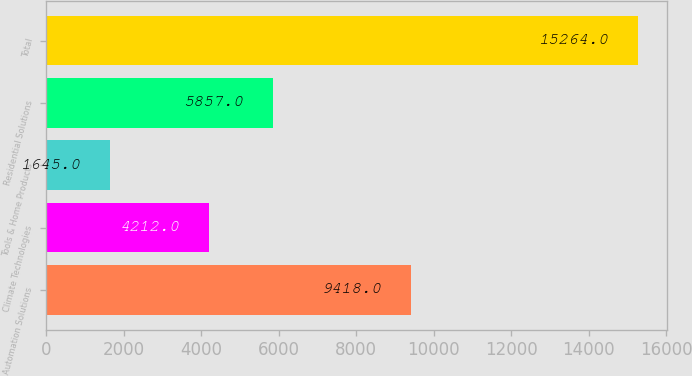Convert chart. <chart><loc_0><loc_0><loc_500><loc_500><bar_chart><fcel>Automation Solutions<fcel>Climate Technologies<fcel>Tools & Home Products<fcel>Residential Solutions<fcel>Total<nl><fcel>9418<fcel>4212<fcel>1645<fcel>5857<fcel>15264<nl></chart> 